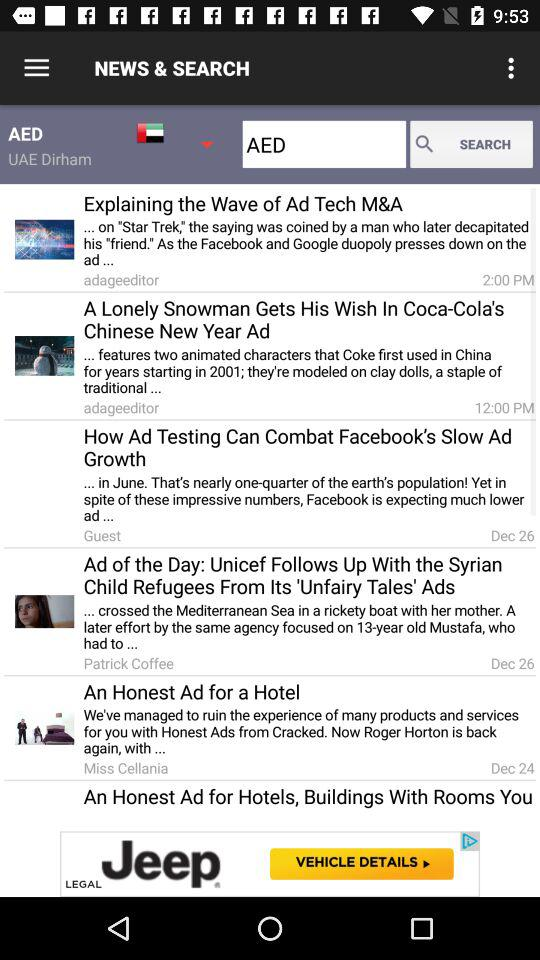What's the published date of the "An Honest Ad for a Hotel" article? The published date of the "An Honest Ad for a Hotel" article is December 24. 